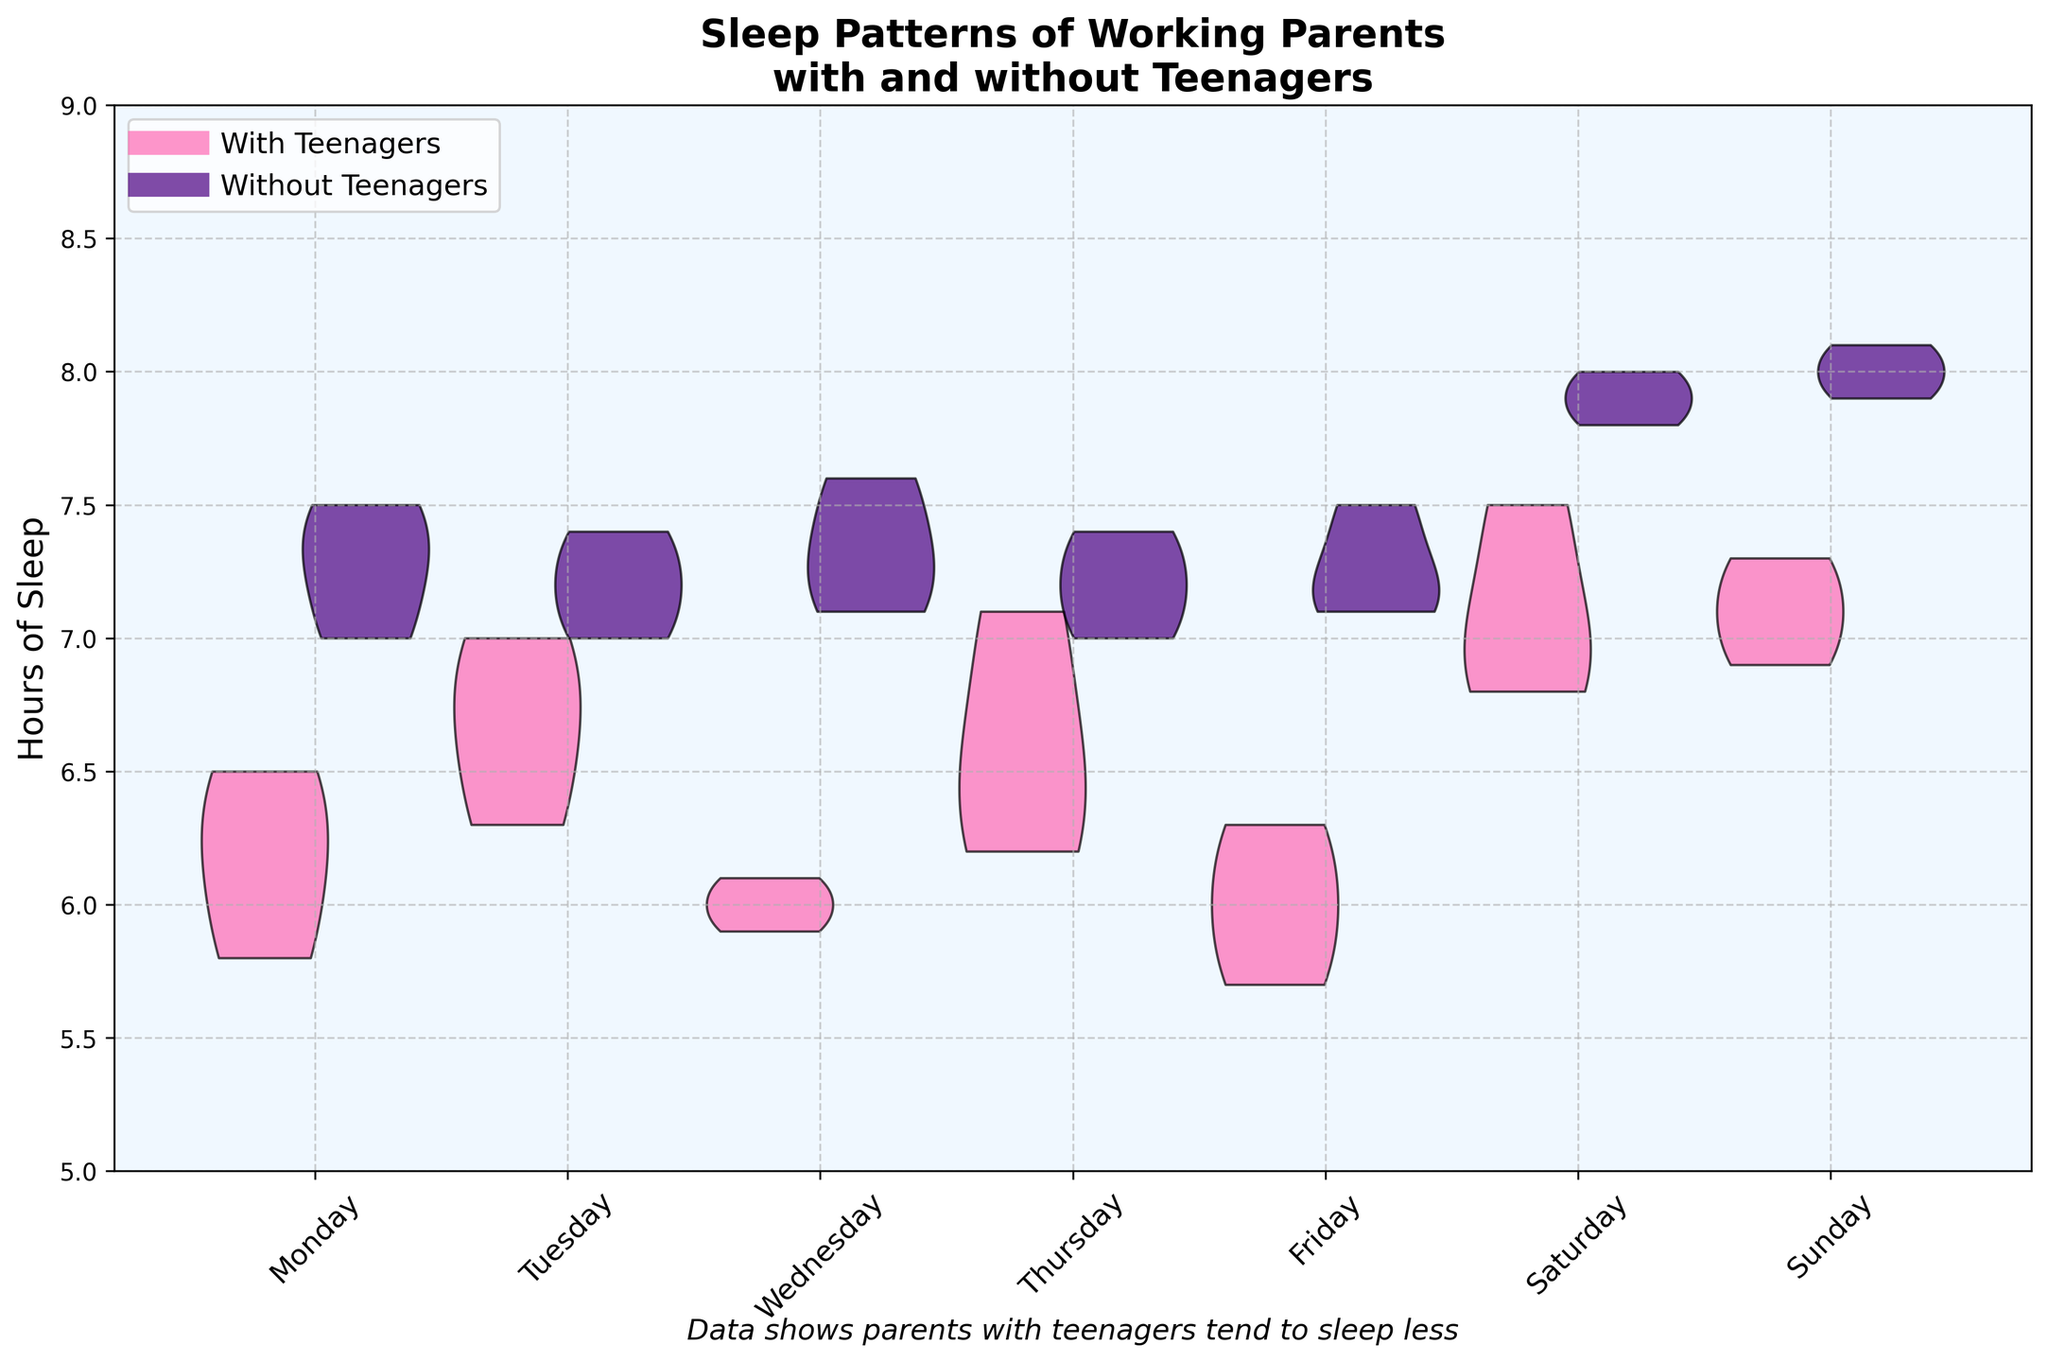What is the title of the chart? The title is clearly mentioned at the top of the chart within the plot area.
Answer: Sleep Patterns of Working Parents with and without Teenagers How many days are depicted on the x-axis? The x-axis labels are the days of the week, and counting them gives a total of seven days.
Answer: 7 days Which group, on average, sleeps more hours on weekends? By comparing the spread and heights of the violin plots on Saturday and Sunday for both groups, the group "Working Parent without Teenagers" has a higher overall distribution of sleep hours.
Answer: Working Parent without Teenagers What colors represent parents with teenagers and parents without teenagers? The colors representing "Working Parent with Teenagers" and "Working Parent without Teenagers" are pink and purple respectively, as shown in the legend.
Answer: Pink and Purple On which day do parents without teenagers seem to get the most sleep? The highest points on the violet-colored violin plots indicate the days with the highest sleep hours, which is Sunday.
Answer: Sunday How does the inequality of sleep duration between the two groups change from weekdays to weekends? The comparison of the width and position of the violin plots shows that the gap widens on weekends, with parents without teenagers sleeping uniformly more than parents with teenagers.
Answer: The gap widens Which day has the least variation in sleep hours for parents with teenagers? The day with the narrowest pink violin plot (least spread) shows the least variation, which appears to be Wednesday.
Answer: Wednesday Is there a day where the median sleep hours look similar between the two groups? By visually comparing the mid-ranges of the overlapping parts of the two plots, both groups have a similar median sleep on Thursday.
Answer: Thursday By how much do sleep hours of parents with teenagers increase on average from Friday to Saturday? Observing the shift upward in the center of the pink violin plot from Friday to Saturday, the average increase can be deduced as around 1.2 hours.
Answer: ~1.2 hours 